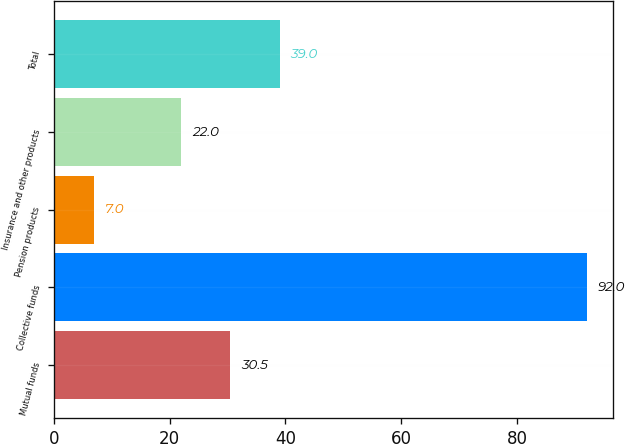Convert chart. <chart><loc_0><loc_0><loc_500><loc_500><bar_chart><fcel>Mutual funds<fcel>Collective funds<fcel>Pension products<fcel>Insurance and other products<fcel>Total<nl><fcel>30.5<fcel>92<fcel>7<fcel>22<fcel>39<nl></chart> 